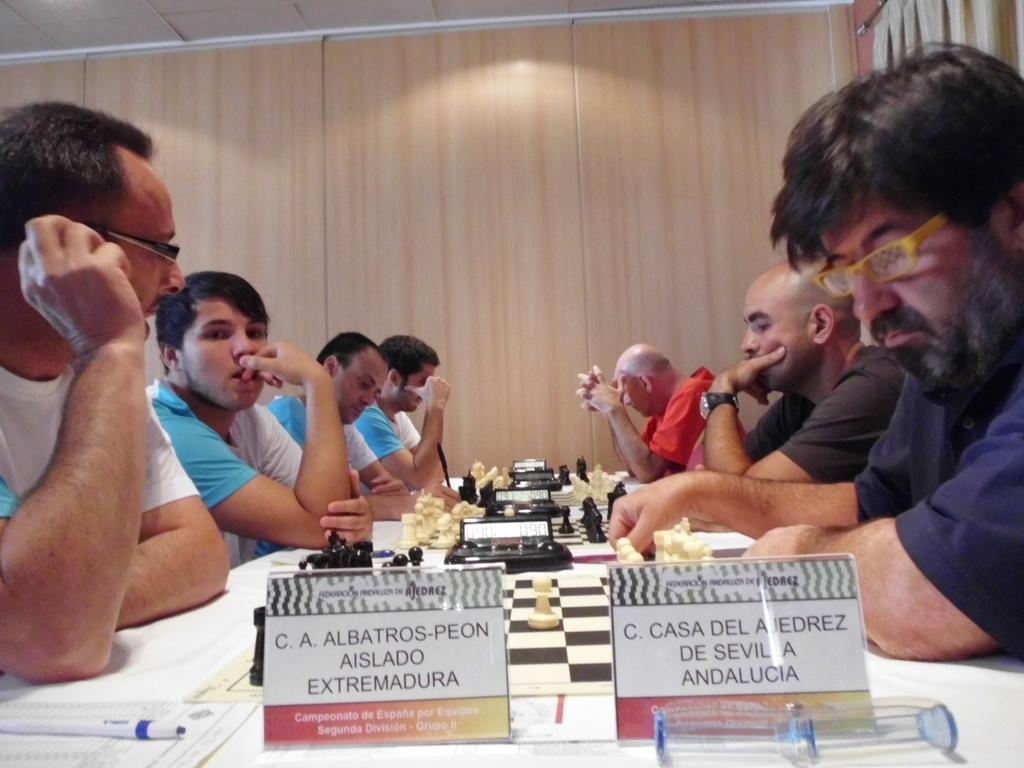What activity are the persons in the image engaged in? The persons in the image are playing chess. How are the persons paired up in the game? Each person has an opponent in front of them. What type of train can be seen passing by in the image? There is no train present in the image; it features a group of persons playing chess. 